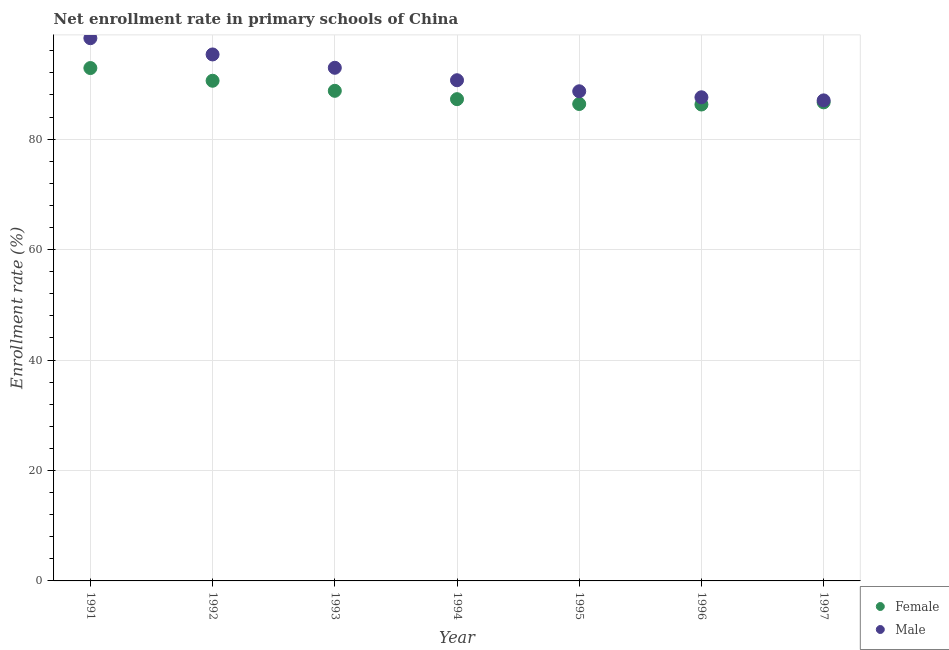How many different coloured dotlines are there?
Make the answer very short. 2. What is the enrollment rate of female students in 1997?
Your answer should be very brief. 86.67. Across all years, what is the maximum enrollment rate of male students?
Your answer should be compact. 98.29. Across all years, what is the minimum enrollment rate of male students?
Keep it short and to the point. 87.02. In which year was the enrollment rate of male students maximum?
Make the answer very short. 1991. What is the total enrollment rate of male students in the graph?
Offer a very short reply. 640.51. What is the difference between the enrollment rate of female students in 1991 and that in 1993?
Ensure brevity in your answer.  4.12. What is the difference between the enrollment rate of male students in 1994 and the enrollment rate of female students in 1995?
Your response must be concise. 4.31. What is the average enrollment rate of female students per year?
Ensure brevity in your answer.  88.4. In the year 1996, what is the difference between the enrollment rate of male students and enrollment rate of female students?
Make the answer very short. 1.31. What is the ratio of the enrollment rate of male students in 1994 to that in 1996?
Offer a very short reply. 1.04. Is the enrollment rate of female students in 1993 less than that in 1996?
Provide a succinct answer. No. What is the difference between the highest and the second highest enrollment rate of female students?
Give a very brief answer. 2.3. What is the difference between the highest and the lowest enrollment rate of male students?
Ensure brevity in your answer.  11.26. Is the sum of the enrollment rate of female students in 1992 and 1994 greater than the maximum enrollment rate of male students across all years?
Your response must be concise. Yes. How many dotlines are there?
Your answer should be very brief. 2. What is the difference between two consecutive major ticks on the Y-axis?
Keep it short and to the point. 20. How many legend labels are there?
Give a very brief answer. 2. What is the title of the graph?
Offer a terse response. Net enrollment rate in primary schools of China. Does "External balance on goods" appear as one of the legend labels in the graph?
Offer a terse response. No. What is the label or title of the X-axis?
Your answer should be very brief. Year. What is the label or title of the Y-axis?
Offer a terse response. Enrollment rate (%). What is the Enrollment rate (%) of Female in 1991?
Provide a succinct answer. 92.88. What is the Enrollment rate (%) of Male in 1991?
Keep it short and to the point. 98.29. What is the Enrollment rate (%) in Female in 1992?
Give a very brief answer. 90.58. What is the Enrollment rate (%) in Male in 1992?
Your answer should be compact. 95.34. What is the Enrollment rate (%) in Female in 1993?
Ensure brevity in your answer.  88.75. What is the Enrollment rate (%) in Male in 1993?
Ensure brevity in your answer.  92.93. What is the Enrollment rate (%) of Female in 1994?
Provide a succinct answer. 87.24. What is the Enrollment rate (%) in Male in 1994?
Offer a very short reply. 90.67. What is the Enrollment rate (%) in Female in 1995?
Ensure brevity in your answer.  86.37. What is the Enrollment rate (%) in Male in 1995?
Provide a succinct answer. 88.67. What is the Enrollment rate (%) in Female in 1996?
Your response must be concise. 86.28. What is the Enrollment rate (%) of Male in 1996?
Your answer should be very brief. 87.58. What is the Enrollment rate (%) of Female in 1997?
Ensure brevity in your answer.  86.67. What is the Enrollment rate (%) of Male in 1997?
Your response must be concise. 87.02. Across all years, what is the maximum Enrollment rate (%) of Female?
Offer a terse response. 92.88. Across all years, what is the maximum Enrollment rate (%) of Male?
Ensure brevity in your answer.  98.29. Across all years, what is the minimum Enrollment rate (%) in Female?
Provide a short and direct response. 86.28. Across all years, what is the minimum Enrollment rate (%) in Male?
Your answer should be very brief. 87.02. What is the total Enrollment rate (%) of Female in the graph?
Give a very brief answer. 618.77. What is the total Enrollment rate (%) of Male in the graph?
Ensure brevity in your answer.  640.51. What is the difference between the Enrollment rate (%) of Female in 1991 and that in 1992?
Your response must be concise. 2.3. What is the difference between the Enrollment rate (%) in Male in 1991 and that in 1992?
Your answer should be very brief. 2.94. What is the difference between the Enrollment rate (%) in Female in 1991 and that in 1993?
Your answer should be compact. 4.12. What is the difference between the Enrollment rate (%) of Male in 1991 and that in 1993?
Your response must be concise. 5.36. What is the difference between the Enrollment rate (%) in Female in 1991 and that in 1994?
Your answer should be very brief. 5.64. What is the difference between the Enrollment rate (%) of Male in 1991 and that in 1994?
Make the answer very short. 7.61. What is the difference between the Enrollment rate (%) in Female in 1991 and that in 1995?
Keep it short and to the point. 6.51. What is the difference between the Enrollment rate (%) in Male in 1991 and that in 1995?
Your response must be concise. 9.61. What is the difference between the Enrollment rate (%) of Female in 1991 and that in 1996?
Provide a succinct answer. 6.6. What is the difference between the Enrollment rate (%) of Male in 1991 and that in 1996?
Provide a succinct answer. 10.7. What is the difference between the Enrollment rate (%) in Female in 1991 and that in 1997?
Offer a very short reply. 6.21. What is the difference between the Enrollment rate (%) in Male in 1991 and that in 1997?
Provide a succinct answer. 11.26. What is the difference between the Enrollment rate (%) in Female in 1992 and that in 1993?
Provide a succinct answer. 1.82. What is the difference between the Enrollment rate (%) of Male in 1992 and that in 1993?
Your answer should be very brief. 2.42. What is the difference between the Enrollment rate (%) of Female in 1992 and that in 1994?
Make the answer very short. 3.33. What is the difference between the Enrollment rate (%) of Male in 1992 and that in 1994?
Your answer should be very brief. 4.67. What is the difference between the Enrollment rate (%) in Female in 1992 and that in 1995?
Provide a short and direct response. 4.21. What is the difference between the Enrollment rate (%) in Male in 1992 and that in 1995?
Provide a succinct answer. 6.67. What is the difference between the Enrollment rate (%) of Female in 1992 and that in 1996?
Give a very brief answer. 4.3. What is the difference between the Enrollment rate (%) in Male in 1992 and that in 1996?
Provide a short and direct response. 7.76. What is the difference between the Enrollment rate (%) of Female in 1992 and that in 1997?
Provide a short and direct response. 3.91. What is the difference between the Enrollment rate (%) in Male in 1992 and that in 1997?
Your answer should be very brief. 8.32. What is the difference between the Enrollment rate (%) in Female in 1993 and that in 1994?
Offer a very short reply. 1.51. What is the difference between the Enrollment rate (%) of Male in 1993 and that in 1994?
Your response must be concise. 2.25. What is the difference between the Enrollment rate (%) of Female in 1993 and that in 1995?
Provide a short and direct response. 2.39. What is the difference between the Enrollment rate (%) in Male in 1993 and that in 1995?
Your answer should be compact. 4.25. What is the difference between the Enrollment rate (%) of Female in 1993 and that in 1996?
Keep it short and to the point. 2.48. What is the difference between the Enrollment rate (%) in Male in 1993 and that in 1996?
Give a very brief answer. 5.34. What is the difference between the Enrollment rate (%) in Female in 1993 and that in 1997?
Your answer should be compact. 2.08. What is the difference between the Enrollment rate (%) in Male in 1993 and that in 1997?
Ensure brevity in your answer.  5.9. What is the difference between the Enrollment rate (%) in Female in 1994 and that in 1995?
Your response must be concise. 0.88. What is the difference between the Enrollment rate (%) of Male in 1994 and that in 1995?
Offer a very short reply. 2. What is the difference between the Enrollment rate (%) of Female in 1994 and that in 1996?
Offer a very short reply. 0.97. What is the difference between the Enrollment rate (%) of Male in 1994 and that in 1996?
Make the answer very short. 3.09. What is the difference between the Enrollment rate (%) in Female in 1994 and that in 1997?
Your answer should be very brief. 0.57. What is the difference between the Enrollment rate (%) in Male in 1994 and that in 1997?
Ensure brevity in your answer.  3.65. What is the difference between the Enrollment rate (%) of Female in 1995 and that in 1996?
Your answer should be compact. 0.09. What is the difference between the Enrollment rate (%) of Male in 1995 and that in 1996?
Your answer should be very brief. 1.09. What is the difference between the Enrollment rate (%) in Female in 1995 and that in 1997?
Offer a terse response. -0.3. What is the difference between the Enrollment rate (%) of Male in 1995 and that in 1997?
Provide a succinct answer. 1.65. What is the difference between the Enrollment rate (%) of Female in 1996 and that in 1997?
Give a very brief answer. -0.39. What is the difference between the Enrollment rate (%) of Male in 1996 and that in 1997?
Offer a terse response. 0.56. What is the difference between the Enrollment rate (%) in Female in 1991 and the Enrollment rate (%) in Male in 1992?
Ensure brevity in your answer.  -2.46. What is the difference between the Enrollment rate (%) of Female in 1991 and the Enrollment rate (%) of Male in 1993?
Your response must be concise. -0.05. What is the difference between the Enrollment rate (%) in Female in 1991 and the Enrollment rate (%) in Male in 1994?
Provide a succinct answer. 2.21. What is the difference between the Enrollment rate (%) of Female in 1991 and the Enrollment rate (%) of Male in 1995?
Your response must be concise. 4.21. What is the difference between the Enrollment rate (%) of Female in 1991 and the Enrollment rate (%) of Male in 1996?
Offer a very short reply. 5.29. What is the difference between the Enrollment rate (%) in Female in 1991 and the Enrollment rate (%) in Male in 1997?
Offer a very short reply. 5.85. What is the difference between the Enrollment rate (%) of Female in 1992 and the Enrollment rate (%) of Male in 1993?
Offer a terse response. -2.35. What is the difference between the Enrollment rate (%) of Female in 1992 and the Enrollment rate (%) of Male in 1994?
Keep it short and to the point. -0.1. What is the difference between the Enrollment rate (%) of Female in 1992 and the Enrollment rate (%) of Male in 1995?
Offer a terse response. 1.91. What is the difference between the Enrollment rate (%) in Female in 1992 and the Enrollment rate (%) in Male in 1996?
Offer a very short reply. 2.99. What is the difference between the Enrollment rate (%) of Female in 1992 and the Enrollment rate (%) of Male in 1997?
Offer a terse response. 3.55. What is the difference between the Enrollment rate (%) of Female in 1993 and the Enrollment rate (%) of Male in 1994?
Ensure brevity in your answer.  -1.92. What is the difference between the Enrollment rate (%) in Female in 1993 and the Enrollment rate (%) in Male in 1995?
Offer a very short reply. 0.08. What is the difference between the Enrollment rate (%) of Female in 1993 and the Enrollment rate (%) of Male in 1996?
Offer a terse response. 1.17. What is the difference between the Enrollment rate (%) in Female in 1993 and the Enrollment rate (%) in Male in 1997?
Offer a very short reply. 1.73. What is the difference between the Enrollment rate (%) of Female in 1994 and the Enrollment rate (%) of Male in 1995?
Give a very brief answer. -1.43. What is the difference between the Enrollment rate (%) of Female in 1994 and the Enrollment rate (%) of Male in 1996?
Offer a terse response. -0.34. What is the difference between the Enrollment rate (%) in Female in 1994 and the Enrollment rate (%) in Male in 1997?
Provide a short and direct response. 0.22. What is the difference between the Enrollment rate (%) in Female in 1995 and the Enrollment rate (%) in Male in 1996?
Your response must be concise. -1.22. What is the difference between the Enrollment rate (%) in Female in 1995 and the Enrollment rate (%) in Male in 1997?
Offer a terse response. -0.66. What is the difference between the Enrollment rate (%) of Female in 1996 and the Enrollment rate (%) of Male in 1997?
Your response must be concise. -0.75. What is the average Enrollment rate (%) of Female per year?
Your answer should be very brief. 88.4. What is the average Enrollment rate (%) of Male per year?
Keep it short and to the point. 91.5. In the year 1991, what is the difference between the Enrollment rate (%) of Female and Enrollment rate (%) of Male?
Ensure brevity in your answer.  -5.41. In the year 1992, what is the difference between the Enrollment rate (%) in Female and Enrollment rate (%) in Male?
Make the answer very short. -4.76. In the year 1993, what is the difference between the Enrollment rate (%) of Female and Enrollment rate (%) of Male?
Provide a short and direct response. -4.17. In the year 1994, what is the difference between the Enrollment rate (%) in Female and Enrollment rate (%) in Male?
Give a very brief answer. -3.43. In the year 1995, what is the difference between the Enrollment rate (%) in Female and Enrollment rate (%) in Male?
Keep it short and to the point. -2.3. In the year 1996, what is the difference between the Enrollment rate (%) of Female and Enrollment rate (%) of Male?
Offer a terse response. -1.31. In the year 1997, what is the difference between the Enrollment rate (%) of Female and Enrollment rate (%) of Male?
Provide a short and direct response. -0.35. What is the ratio of the Enrollment rate (%) of Female in 1991 to that in 1992?
Keep it short and to the point. 1.03. What is the ratio of the Enrollment rate (%) of Male in 1991 to that in 1992?
Offer a terse response. 1.03. What is the ratio of the Enrollment rate (%) in Female in 1991 to that in 1993?
Offer a very short reply. 1.05. What is the ratio of the Enrollment rate (%) in Male in 1991 to that in 1993?
Offer a terse response. 1.06. What is the ratio of the Enrollment rate (%) of Female in 1991 to that in 1994?
Offer a terse response. 1.06. What is the ratio of the Enrollment rate (%) of Male in 1991 to that in 1994?
Provide a short and direct response. 1.08. What is the ratio of the Enrollment rate (%) of Female in 1991 to that in 1995?
Your response must be concise. 1.08. What is the ratio of the Enrollment rate (%) in Male in 1991 to that in 1995?
Provide a succinct answer. 1.11. What is the ratio of the Enrollment rate (%) in Female in 1991 to that in 1996?
Your answer should be compact. 1.08. What is the ratio of the Enrollment rate (%) of Male in 1991 to that in 1996?
Your answer should be very brief. 1.12. What is the ratio of the Enrollment rate (%) in Female in 1991 to that in 1997?
Your response must be concise. 1.07. What is the ratio of the Enrollment rate (%) in Male in 1991 to that in 1997?
Ensure brevity in your answer.  1.13. What is the ratio of the Enrollment rate (%) in Female in 1992 to that in 1993?
Offer a very short reply. 1.02. What is the ratio of the Enrollment rate (%) of Male in 1992 to that in 1993?
Make the answer very short. 1.03. What is the ratio of the Enrollment rate (%) of Female in 1992 to that in 1994?
Offer a terse response. 1.04. What is the ratio of the Enrollment rate (%) of Male in 1992 to that in 1994?
Ensure brevity in your answer.  1.05. What is the ratio of the Enrollment rate (%) in Female in 1992 to that in 1995?
Keep it short and to the point. 1.05. What is the ratio of the Enrollment rate (%) of Male in 1992 to that in 1995?
Your answer should be compact. 1.08. What is the ratio of the Enrollment rate (%) of Female in 1992 to that in 1996?
Keep it short and to the point. 1.05. What is the ratio of the Enrollment rate (%) in Male in 1992 to that in 1996?
Offer a very short reply. 1.09. What is the ratio of the Enrollment rate (%) of Female in 1992 to that in 1997?
Your response must be concise. 1.05. What is the ratio of the Enrollment rate (%) of Male in 1992 to that in 1997?
Provide a short and direct response. 1.1. What is the ratio of the Enrollment rate (%) in Female in 1993 to that in 1994?
Offer a terse response. 1.02. What is the ratio of the Enrollment rate (%) of Male in 1993 to that in 1994?
Ensure brevity in your answer.  1.02. What is the ratio of the Enrollment rate (%) of Female in 1993 to that in 1995?
Give a very brief answer. 1.03. What is the ratio of the Enrollment rate (%) of Male in 1993 to that in 1995?
Make the answer very short. 1.05. What is the ratio of the Enrollment rate (%) of Female in 1993 to that in 1996?
Your answer should be compact. 1.03. What is the ratio of the Enrollment rate (%) of Male in 1993 to that in 1996?
Offer a very short reply. 1.06. What is the ratio of the Enrollment rate (%) in Male in 1993 to that in 1997?
Offer a terse response. 1.07. What is the ratio of the Enrollment rate (%) in Female in 1994 to that in 1995?
Make the answer very short. 1.01. What is the ratio of the Enrollment rate (%) of Male in 1994 to that in 1995?
Your answer should be compact. 1.02. What is the ratio of the Enrollment rate (%) of Female in 1994 to that in 1996?
Provide a succinct answer. 1.01. What is the ratio of the Enrollment rate (%) of Male in 1994 to that in 1996?
Your answer should be compact. 1.04. What is the ratio of the Enrollment rate (%) in Female in 1994 to that in 1997?
Keep it short and to the point. 1.01. What is the ratio of the Enrollment rate (%) in Male in 1994 to that in 1997?
Your answer should be very brief. 1.04. What is the ratio of the Enrollment rate (%) in Female in 1995 to that in 1996?
Provide a short and direct response. 1. What is the ratio of the Enrollment rate (%) of Male in 1995 to that in 1996?
Keep it short and to the point. 1.01. What is the ratio of the Enrollment rate (%) in Male in 1995 to that in 1997?
Provide a succinct answer. 1.02. What is the ratio of the Enrollment rate (%) in Female in 1996 to that in 1997?
Ensure brevity in your answer.  1. What is the ratio of the Enrollment rate (%) in Male in 1996 to that in 1997?
Ensure brevity in your answer.  1.01. What is the difference between the highest and the second highest Enrollment rate (%) in Female?
Provide a succinct answer. 2.3. What is the difference between the highest and the second highest Enrollment rate (%) of Male?
Your response must be concise. 2.94. What is the difference between the highest and the lowest Enrollment rate (%) of Female?
Provide a succinct answer. 6.6. What is the difference between the highest and the lowest Enrollment rate (%) of Male?
Keep it short and to the point. 11.26. 